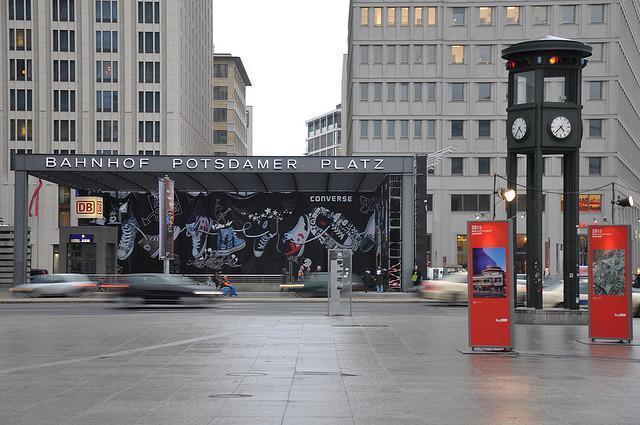One will come here if one wants to do what?
Pick the correct solution from the four options below to address the question.
Options: Order takeout, buy shoes, see movie, take train. Take train. 